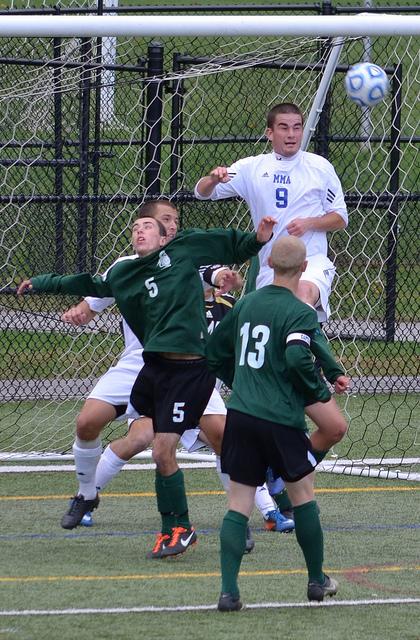What brand of shoes is the person wearing number 5 shirt have on?
Answer briefly. Nike. What is the number of the man in white?
Be succinct. 9. What are the people going after?
Be succinct. Soccer ball. 